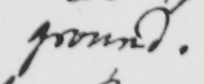What text is written in this handwritten line? ground . 